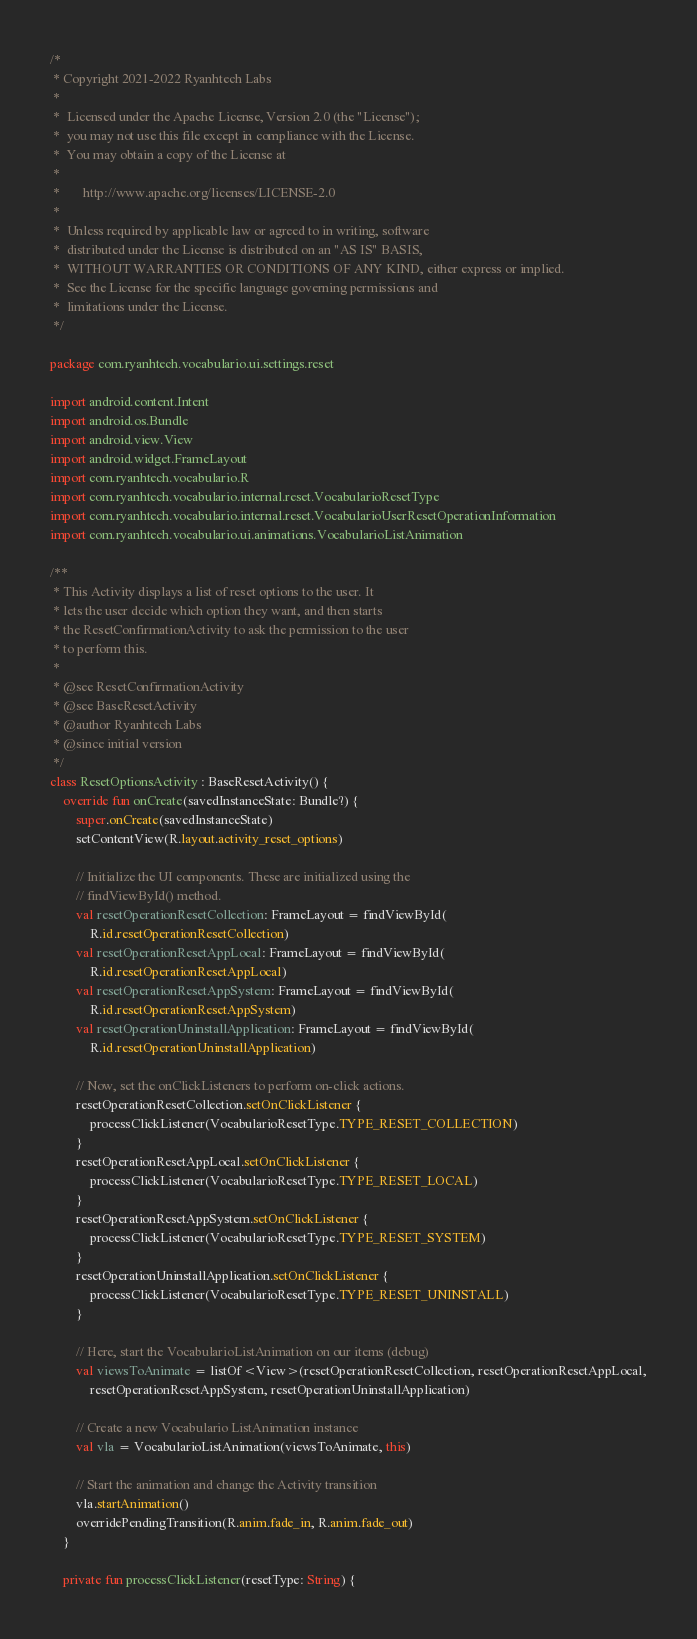<code> <loc_0><loc_0><loc_500><loc_500><_Kotlin_>/*
 * Copyright 2021-2022 Ryanhtech Labs
 *
 *  Licensed under the Apache License, Version 2.0 (the "License");
 *  you may not use this file except in compliance with the License.
 *  You may obtain a copy of the License at
 *
 *       http://www.apache.org/licenses/LICENSE-2.0
 *
 *  Unless required by applicable law or agreed to in writing, software
 *  distributed under the License is distributed on an "AS IS" BASIS,
 *  WITHOUT WARRANTIES OR CONDITIONS OF ANY KIND, either express or implied.
 *  See the License for the specific language governing permissions and
 *  limitations under the License.
 */

package com.ryanhtech.vocabulario.ui.settings.reset

import android.content.Intent
import android.os.Bundle
import android.view.View
import android.widget.FrameLayout
import com.ryanhtech.vocabulario.R
import com.ryanhtech.vocabulario.internal.reset.VocabularioResetType
import com.ryanhtech.vocabulario.internal.reset.VocabularioUserResetOperationInformation
import com.ryanhtech.vocabulario.ui.animations.VocabularioListAnimation

/**
 * This Activity displays a list of reset options to the user. It
 * lets the user decide which option they want, and then starts
 * the ResetConfirmationActivity to ask the permission to the user
 * to perform this.
 *
 * @see ResetConfirmationActivity
 * @see BaseResetActivity
 * @author Ryanhtech Labs
 * @since initial version
 */
class ResetOptionsActivity : BaseResetActivity() {
    override fun onCreate(savedInstanceState: Bundle?) {
        super.onCreate(savedInstanceState)
        setContentView(R.layout.activity_reset_options)

        // Initialize the UI components. These are initialized using the
        // findViewById() method.
        val resetOperationResetCollection: FrameLayout = findViewById(
            R.id.resetOperationResetCollection)
        val resetOperationResetAppLocal: FrameLayout = findViewById(
            R.id.resetOperationResetAppLocal)
        val resetOperationResetAppSystem: FrameLayout = findViewById(
            R.id.resetOperationResetAppSystem)
        val resetOperationUninstallApplication: FrameLayout = findViewById(
            R.id.resetOperationUninstallApplication)

        // Now, set the onClickListeners to perform on-click actions.
        resetOperationResetCollection.setOnClickListener {
            processClickListener(VocabularioResetType.TYPE_RESET_COLLECTION)
        }
        resetOperationResetAppLocal.setOnClickListener {
            processClickListener(VocabularioResetType.TYPE_RESET_LOCAL)
        }
        resetOperationResetAppSystem.setOnClickListener {
            processClickListener(VocabularioResetType.TYPE_RESET_SYSTEM)
        }
        resetOperationUninstallApplication.setOnClickListener {
            processClickListener(VocabularioResetType.TYPE_RESET_UNINSTALL)
        }

        // Here, start the VocabularioListAnimation on our items (debug)
        val viewsToAnimate = listOf<View>(resetOperationResetCollection, resetOperationResetAppLocal,
            resetOperationResetAppSystem, resetOperationUninstallApplication)

        // Create a new Vocabulario ListAnimation instance
        val vla = VocabularioListAnimation(viewsToAnimate, this)

        // Start the animation and change the Activity transition
        vla.startAnimation()
        overridePendingTransition(R.anim.fade_in, R.anim.fade_out)
    }

    private fun processClickListener(resetType: String) {</code> 